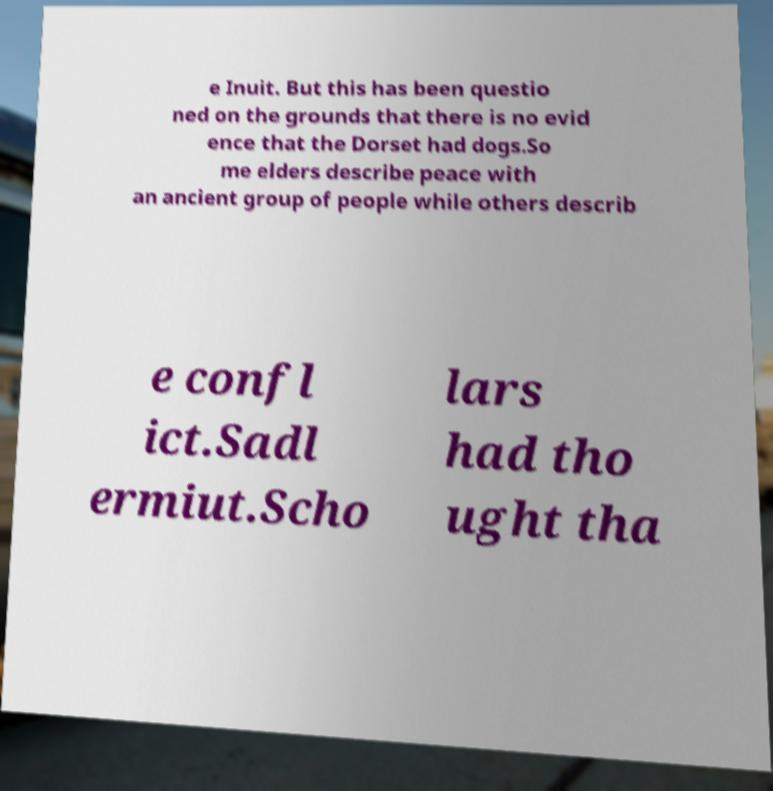Please identify and transcribe the text found in this image. e Inuit. But this has been questio ned on the grounds that there is no evid ence that the Dorset had dogs.So me elders describe peace with an ancient group of people while others describ e confl ict.Sadl ermiut.Scho lars had tho ught tha 